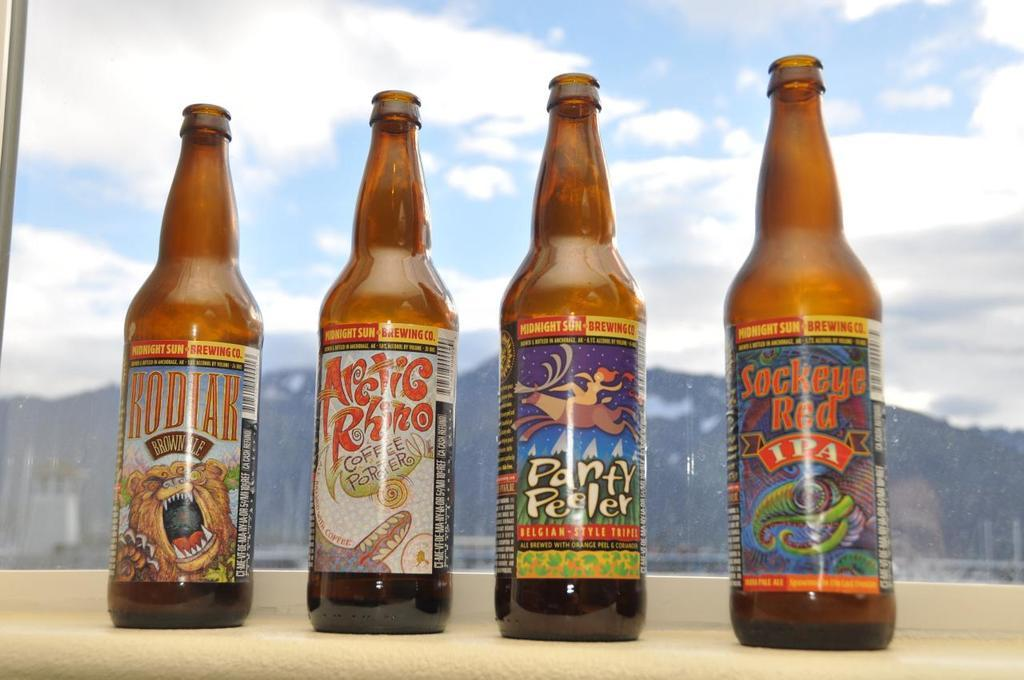Provide a one-sentence caption for the provided image. Four beer bottles are lined up on a windowsill and one is called Arctic Rhino. 